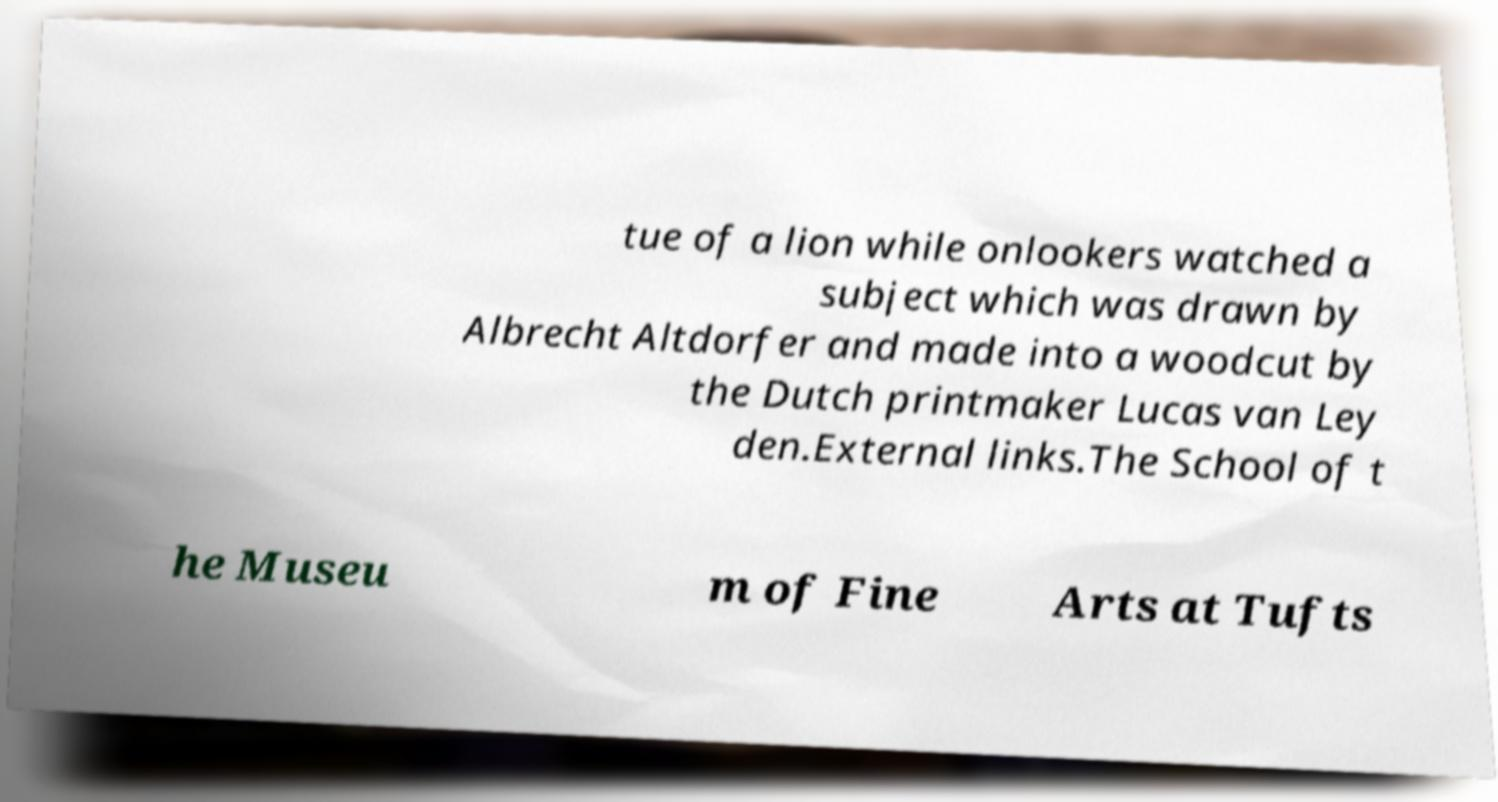Please identify and transcribe the text found in this image. tue of a lion while onlookers watched a subject which was drawn by Albrecht Altdorfer and made into a woodcut by the Dutch printmaker Lucas van Ley den.External links.The School of t he Museu m of Fine Arts at Tufts 